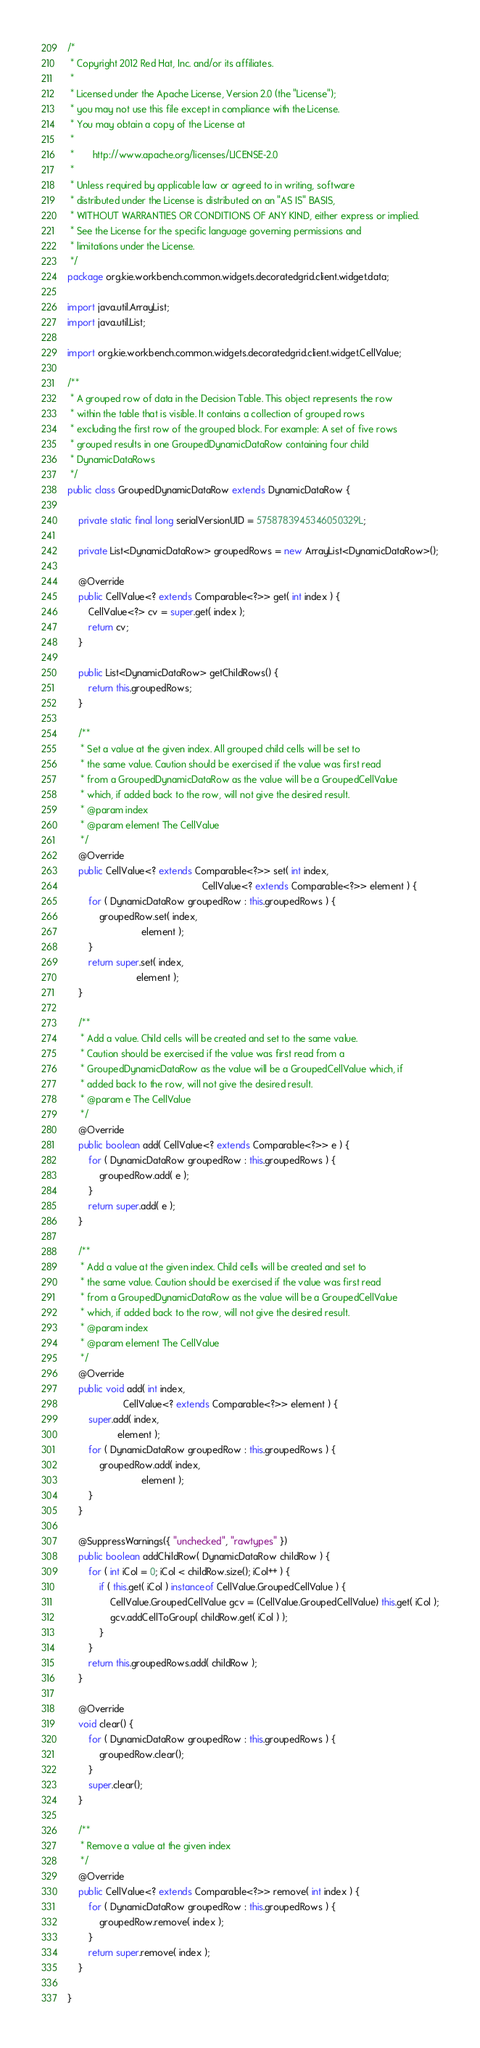Convert code to text. <code><loc_0><loc_0><loc_500><loc_500><_Java_>/*
 * Copyright 2012 Red Hat, Inc. and/or its affiliates.
 *
 * Licensed under the Apache License, Version 2.0 (the "License");
 * you may not use this file except in compliance with the License.
 * You may obtain a copy of the License at
 *
 *       http://www.apache.org/licenses/LICENSE-2.0
 *
 * Unless required by applicable law or agreed to in writing, software
 * distributed under the License is distributed on an "AS IS" BASIS,
 * WITHOUT WARRANTIES OR CONDITIONS OF ANY KIND, either express or implied.
 * See the License for the specific language governing permissions and
 * limitations under the License.
 */
package org.kie.workbench.common.widgets.decoratedgrid.client.widget.data;

import java.util.ArrayList;
import java.util.List;

import org.kie.workbench.common.widgets.decoratedgrid.client.widget.CellValue;

/**
 * A grouped row of data in the Decision Table. This object represents the row
 * within the table that is visible. It contains a collection of grouped rows
 * excluding the first row of the grouped block. For example: A set of five rows
 * grouped results in one GroupedDynamicDataRow containing four child
 * DynamicDataRows
 */
public class GroupedDynamicDataRow extends DynamicDataRow {

    private static final long serialVersionUID = 5758783945346050329L;

    private List<DynamicDataRow> groupedRows = new ArrayList<DynamicDataRow>();

    @Override
    public CellValue<? extends Comparable<?>> get( int index ) {
        CellValue<?> cv = super.get( index );
        return cv;
    }

    public List<DynamicDataRow> getChildRows() {
        return this.groupedRows;
    }

    /**
     * Set a value at the given index. All grouped child cells will be set to
     * the same value. Caution should be exercised if the value was first read
     * from a GroupedDynamicDataRow as the value will be a GroupedCellValue
     * which, if added back to the row, will not give the desired result.
     * @param index
     * @param element The CellValue
     */
    @Override
    public CellValue<? extends Comparable<?>> set( int index,
                                                   CellValue<? extends Comparable<?>> element ) {
        for ( DynamicDataRow groupedRow : this.groupedRows ) {
            groupedRow.set( index,
                            element );
        }
        return super.set( index,
                          element );
    }

    /**
     * Add a value. Child cells will be created and set to the same value.
     * Caution should be exercised if the value was first read from a
     * GroupedDynamicDataRow as the value will be a GroupedCellValue which, if
     * added back to the row, will not give the desired result.
     * @param e The CellValue
     */
    @Override
    public boolean add( CellValue<? extends Comparable<?>> e ) {
        for ( DynamicDataRow groupedRow : this.groupedRows ) {
            groupedRow.add( e );
        }
        return super.add( e );
    }

    /**
     * Add a value at the given index. Child cells will be created and set to
     * the same value. Caution should be exercised if the value was first read
     * from a GroupedDynamicDataRow as the value will be a GroupedCellValue
     * which, if added back to the row, will not give the desired result.
     * @param index
     * @param element The CellValue
     */
    @Override
    public void add( int index,
                     CellValue<? extends Comparable<?>> element ) {
        super.add( index,
                   element );
        for ( DynamicDataRow groupedRow : this.groupedRows ) {
            groupedRow.add( index,
                            element );
        }
    }

    @SuppressWarnings({ "unchecked", "rawtypes" })
    public boolean addChildRow( DynamicDataRow childRow ) {
        for ( int iCol = 0; iCol < childRow.size(); iCol++ ) {
            if ( this.get( iCol ) instanceof CellValue.GroupedCellValue ) {
                CellValue.GroupedCellValue gcv = (CellValue.GroupedCellValue) this.get( iCol );
                gcv.addCellToGroup( childRow.get( iCol ) );
            }
        }
        return this.groupedRows.add( childRow );
    }

    @Override
    void clear() {
        for ( DynamicDataRow groupedRow : this.groupedRows ) {
            groupedRow.clear();
        }
        super.clear();
    }

    /**
     * Remove a value at the given index
     */
    @Override
    public CellValue<? extends Comparable<?>> remove( int index ) {
        for ( DynamicDataRow groupedRow : this.groupedRows ) {
            groupedRow.remove( index );
        }
        return super.remove( index );
    }

}
</code> 